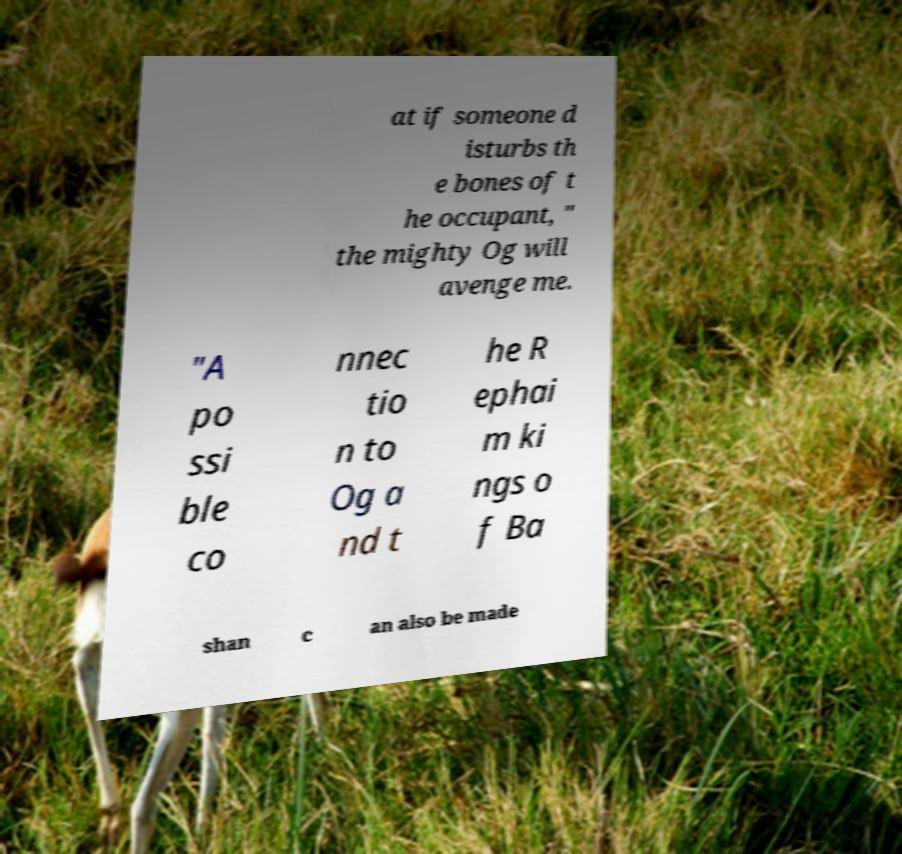I need the written content from this picture converted into text. Can you do that? at if someone d isturbs th e bones of t he occupant, " the mighty Og will avenge me. "A po ssi ble co nnec tio n to Og a nd t he R ephai m ki ngs o f Ba shan c an also be made 